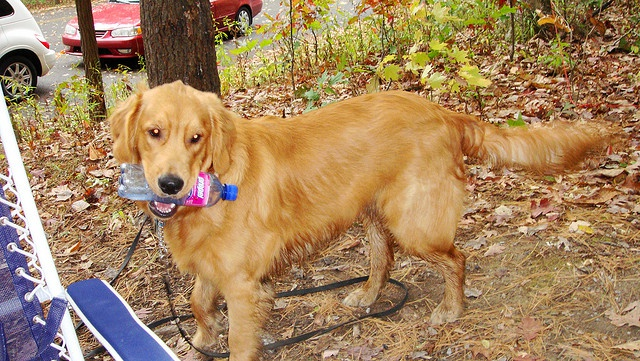Describe the objects in this image and their specific colors. I can see dog in black, tan, and red tones, chair in black, white, blue, purple, and navy tones, car in black, white, maroon, and lightpink tones, car in black, white, darkgray, and olive tones, and bottle in black, darkgray, lavender, and gray tones in this image. 